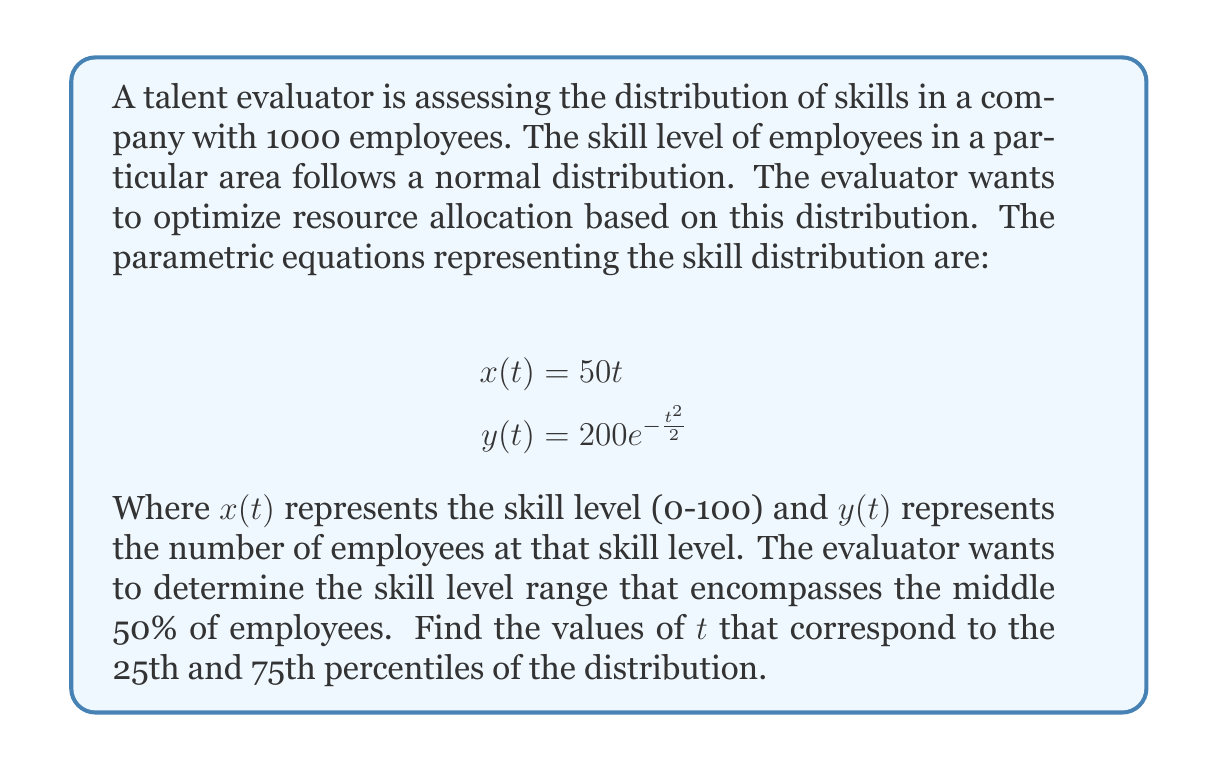Can you answer this question? To solve this problem, we need to follow these steps:

1) First, we need to find the total area under the curve, which represents the total number of employees:

   $$\text{Total Area} = \int_{-\infty}^{\infty} y(t) dx = \int_{-\infty}^{\infty} 200e^{-\frac{t^2}{2}} \cdot 50 dt = 10000\sqrt{2\pi}$$

2) The middle 50% of employees are between the 25th and 75th percentiles. We need to find the $t$ values where the area under the curve reaches 25% and 75% of the total area.

3) For the 25th percentile:
   $$\int_{-\infty}^{t_{25}} 200e^{-\frac{t^2}{2}} \cdot 50 dt = 0.25 \cdot 10000\sqrt{2\pi}$$

4) Simplifying:
   $$5000\sqrt{2\pi} \cdot \text{erf}\left(\frac{t_{25}}{\sqrt{2}}\right) = 2500\sqrt{2\pi}$$

5) Solving this equation:
   $$\text{erf}\left(\frac{t_{25}}{\sqrt{2}}\right) = 0.5$$
   $$\frac{t_{25}}{\sqrt{2}} = \text{erf}^{-1}(0.5) \approx 0.4769$$
   $$t_{25} \approx 0.4769\sqrt{2} \approx 0.6745$$

6) For the 75th percentile, we follow a similar process:
   $$\text{erf}\left(\frac{t_{75}}{\sqrt{2}}\right) = 0.75$$
   $$\frac{t_{75}}{\sqrt{2}} = \text{erf}^{-1}(0.75) \approx 0.7554$$
   $$t_{75} \approx 0.7554\sqrt{2} \approx 1.0682$$

7) To find the corresponding skill levels, we use the $x(t)$ equation:
   $$x(t_{25}) = 50 \cdot 0.6745 \approx 33.73$$
   $$x(t_{75}) = 50 \cdot 1.0682 \approx 53.41$$
Answer: The middle 50% of employees have skill levels between approximately 33.73 and 53.41, corresponding to $t$ values of 0.6745 and 1.0682 respectively. 